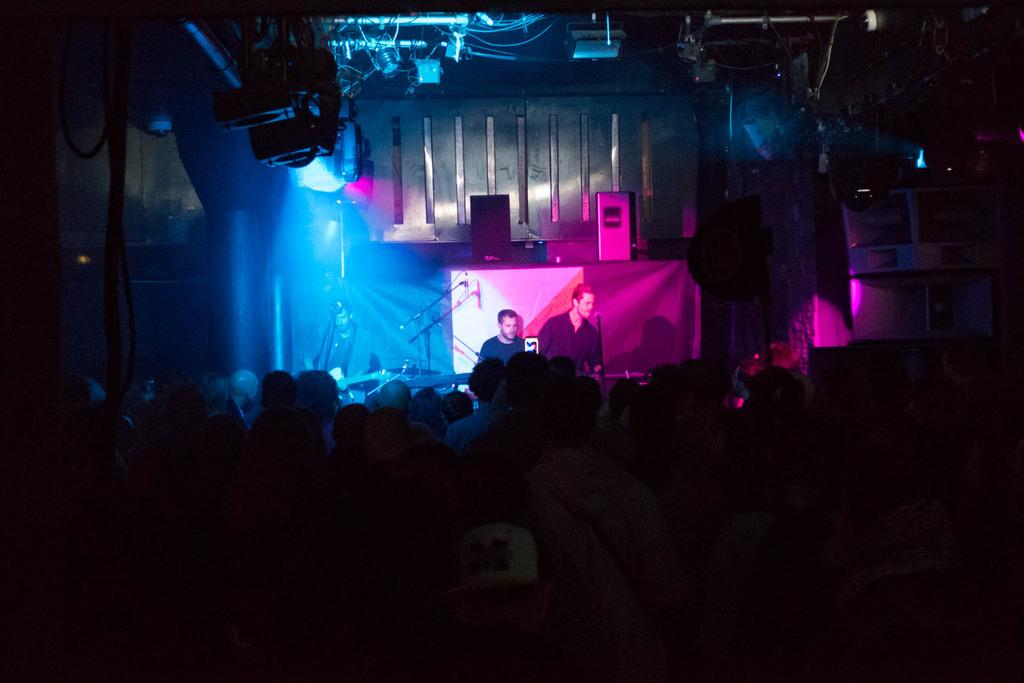What can be seen in the image? There is an audience in the image, along with three people playing musical instruments. What equipment is present to help amplify the sound of the musicians? There are microphones in front of the musicians and speakers in the image. What type of lighting is used in the image? There are focusing lights in the image. What type of scale is being used by the musicians in the image? There is no scale present in the image; the musicians are playing musical instruments. What type of beam is being used to support the speakers in the image? There is no beam visible in the image; the speakers are simply placed on the ground or a surface. 